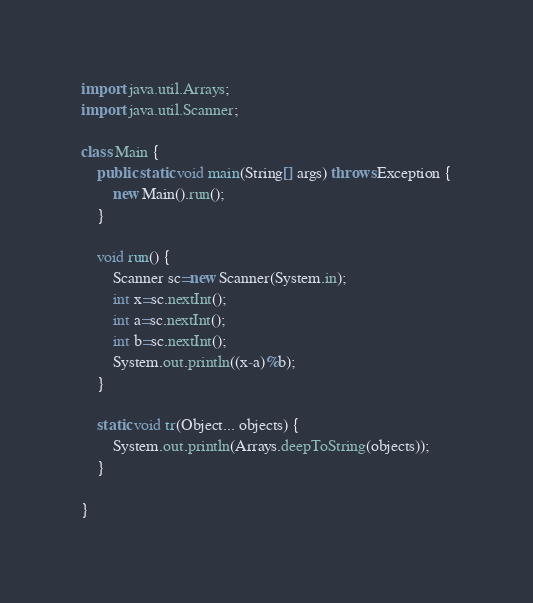<code> <loc_0><loc_0><loc_500><loc_500><_Java_>import java.util.Arrays;
import java.util.Scanner;

class Main {
	public static void main(String[] args) throws Exception {
		new Main().run();
	}
	
	void run() {
		Scanner sc=new Scanner(System.in);
		int x=sc.nextInt();
		int a=sc.nextInt();
		int b=sc.nextInt();
		System.out.println((x-a)%b);
	}
	
	static void tr(Object... objects) {
		System.out.println(Arrays.deepToString(objects));
	}
	
}
</code> 